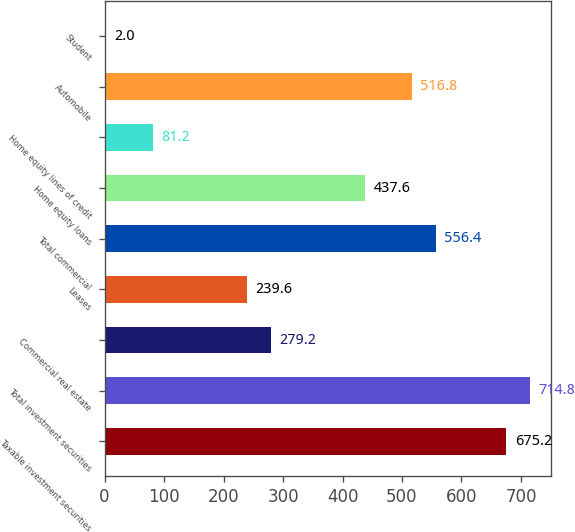Convert chart to OTSL. <chart><loc_0><loc_0><loc_500><loc_500><bar_chart><fcel>Taxable investment securities<fcel>Total investment securities<fcel>Commercial real estate<fcel>Leases<fcel>Total commercial<fcel>Home equity loans<fcel>Home equity lines of credit<fcel>Automobile<fcel>Student<nl><fcel>675.2<fcel>714.8<fcel>279.2<fcel>239.6<fcel>556.4<fcel>437.6<fcel>81.2<fcel>516.8<fcel>2<nl></chart> 